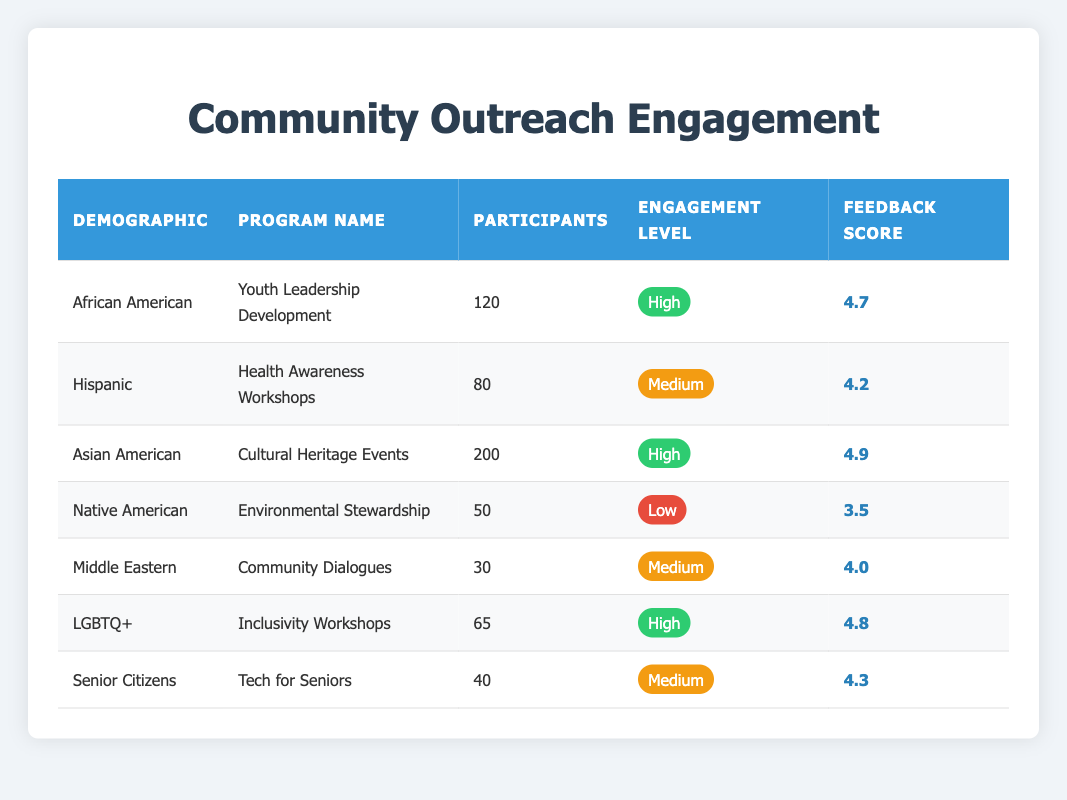What is the engagement level for the Asian American demographic in the Cultural Heritage Events program? The engagement level for the Asian American demographic is found in the corresponding row under the "Engagement Level" column, which shows a "High" engagement level.
Answer: High How many participants were involved in the Youth Leadership Development program? The number of participants in the Youth Leadership Development program for the African American demographic is in the same row under the "Participants" column, which shows 120 participants.
Answer: 120 Which program had the lowest engagement level and how many participants were there? To determine this, we can scan the "Engagement Level" column for the lowest value, which is "Low" for the Environmental Stewardship program. Looking to the "Participants" column in the same row, it displays 50 participants.
Answer: Environmental Stewardship, 50 True or False: The Health Awareness Workshops received a feedback score of 4.5 or higher. Reference the "Feedback Score" for the Health Awareness Workshops row, which shows a score of 4.2. Since 4.2 is less than 4.5, the statement is false.
Answer: False What is the average feedback score for programs with a high engagement level? Programs with high engagement levels are Youth Leadership Development (4.7), Cultural Heritage Events (4.9), and Inclusivity Workshops (4.8). The sum of these scores is (4.7 + 4.9 + 4.8) = 14.4, and there are 3 programs, so the average is 14.4 / 3 = 4.8.
Answer: 4.8 What percentage of participants in the Community Dialogues program rated the engagement level as Medium? The Community Dialogues program had 30 participants. Since the engagement level "Medium" is noted as the engagement level, we can calculate the proportion of this specific program out of the total participants involved in programs rated Medium. The total number of participants from Medium engagement levels (Health Awareness Workshops - 80, Community Dialogues - 30, Tech for Seniors - 40) is 150. Thus, the percentage is (30 / 150) * 100 = 20%.
Answer: 20% How many more participants engaged in the Cultural Heritage Events than in the Environmental Stewardship program? The Cultural Heritage Events program attracted 200 participants, while the Environmental Stewardship program had 50 participants. The difference in participants is calculated by subtracting: 200 - 50 = 150.
Answer: 150 Which demographic had the highest feedback score, and what was it? Scanning through the feedback scores, the Asian American demographic in the Cultural Heritage Events program shows the highest score at 4.9.
Answer: Asian American, 4.9 Which demographic engaged in more programs, high or medium level? We analyze the table for demographics under high engagement levels (African American, Asian American, LGBTQ+) totaling 3, and under medium levels (Hispanic, Middle Eastern, Senior Citizens) which also totals 3. Thus, both categories have the same number of engaged demographics.
Answer: Same number 